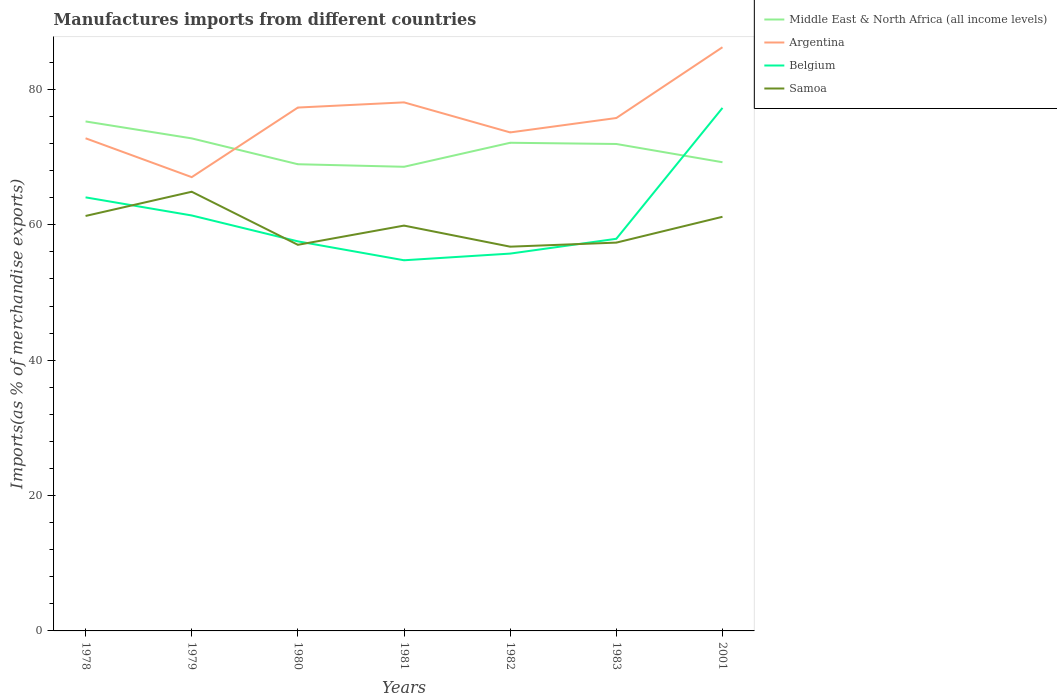Does the line corresponding to Belgium intersect with the line corresponding to Argentina?
Provide a succinct answer. No. Across all years, what is the maximum percentage of imports to different countries in Belgium?
Offer a terse response. 54.77. What is the total percentage of imports to different countries in Argentina in the graph?
Make the answer very short. -10.28. What is the difference between the highest and the second highest percentage of imports to different countries in Belgium?
Make the answer very short. 22.51. What is the difference between the highest and the lowest percentage of imports to different countries in Samoa?
Keep it short and to the point. 4. How many years are there in the graph?
Your answer should be compact. 7. Are the values on the major ticks of Y-axis written in scientific E-notation?
Keep it short and to the point. No. Does the graph contain grids?
Keep it short and to the point. No. What is the title of the graph?
Make the answer very short. Manufactures imports from different countries. Does "St. Vincent and the Grenadines" appear as one of the legend labels in the graph?
Ensure brevity in your answer.  No. What is the label or title of the Y-axis?
Your response must be concise. Imports(as % of merchandise exports). What is the Imports(as % of merchandise exports) of Middle East & North Africa (all income levels) in 1978?
Provide a short and direct response. 75.28. What is the Imports(as % of merchandise exports) of Argentina in 1978?
Provide a succinct answer. 72.79. What is the Imports(as % of merchandise exports) in Belgium in 1978?
Provide a short and direct response. 64.06. What is the Imports(as % of merchandise exports) in Samoa in 1978?
Ensure brevity in your answer.  61.31. What is the Imports(as % of merchandise exports) of Middle East & North Africa (all income levels) in 1979?
Make the answer very short. 72.78. What is the Imports(as % of merchandise exports) in Argentina in 1979?
Ensure brevity in your answer.  67.05. What is the Imports(as % of merchandise exports) in Belgium in 1979?
Provide a succinct answer. 61.39. What is the Imports(as % of merchandise exports) of Samoa in 1979?
Your answer should be very brief. 64.89. What is the Imports(as % of merchandise exports) of Middle East & North Africa (all income levels) in 1980?
Provide a succinct answer. 68.96. What is the Imports(as % of merchandise exports) in Argentina in 1980?
Make the answer very short. 77.33. What is the Imports(as % of merchandise exports) of Belgium in 1980?
Offer a very short reply. 57.56. What is the Imports(as % of merchandise exports) of Samoa in 1980?
Your answer should be very brief. 57.05. What is the Imports(as % of merchandise exports) in Middle East & North Africa (all income levels) in 1981?
Provide a short and direct response. 68.58. What is the Imports(as % of merchandise exports) in Argentina in 1981?
Ensure brevity in your answer.  78.1. What is the Imports(as % of merchandise exports) in Belgium in 1981?
Give a very brief answer. 54.77. What is the Imports(as % of merchandise exports) in Samoa in 1981?
Give a very brief answer. 59.89. What is the Imports(as % of merchandise exports) of Middle East & North Africa (all income levels) in 1982?
Offer a terse response. 72.13. What is the Imports(as % of merchandise exports) in Argentina in 1982?
Keep it short and to the point. 73.66. What is the Imports(as % of merchandise exports) in Belgium in 1982?
Your answer should be very brief. 55.75. What is the Imports(as % of merchandise exports) of Samoa in 1982?
Your answer should be compact. 56.78. What is the Imports(as % of merchandise exports) of Middle East & North Africa (all income levels) in 1983?
Give a very brief answer. 71.95. What is the Imports(as % of merchandise exports) of Argentina in 1983?
Offer a terse response. 75.79. What is the Imports(as % of merchandise exports) of Belgium in 1983?
Offer a terse response. 57.94. What is the Imports(as % of merchandise exports) in Samoa in 1983?
Provide a succinct answer. 57.38. What is the Imports(as % of merchandise exports) of Middle East & North Africa (all income levels) in 2001?
Keep it short and to the point. 69.25. What is the Imports(as % of merchandise exports) in Argentina in 2001?
Offer a very short reply. 86.25. What is the Imports(as % of merchandise exports) of Belgium in 2001?
Keep it short and to the point. 77.28. What is the Imports(as % of merchandise exports) in Samoa in 2001?
Keep it short and to the point. 61.19. Across all years, what is the maximum Imports(as % of merchandise exports) of Middle East & North Africa (all income levels)?
Make the answer very short. 75.28. Across all years, what is the maximum Imports(as % of merchandise exports) in Argentina?
Offer a very short reply. 86.25. Across all years, what is the maximum Imports(as % of merchandise exports) in Belgium?
Provide a short and direct response. 77.28. Across all years, what is the maximum Imports(as % of merchandise exports) of Samoa?
Give a very brief answer. 64.89. Across all years, what is the minimum Imports(as % of merchandise exports) in Middle East & North Africa (all income levels)?
Ensure brevity in your answer.  68.58. Across all years, what is the minimum Imports(as % of merchandise exports) of Argentina?
Your answer should be very brief. 67.05. Across all years, what is the minimum Imports(as % of merchandise exports) of Belgium?
Your answer should be compact. 54.77. Across all years, what is the minimum Imports(as % of merchandise exports) of Samoa?
Offer a very short reply. 56.78. What is the total Imports(as % of merchandise exports) of Middle East & North Africa (all income levels) in the graph?
Your answer should be compact. 498.92. What is the total Imports(as % of merchandise exports) of Argentina in the graph?
Offer a terse response. 530.96. What is the total Imports(as % of merchandise exports) of Belgium in the graph?
Make the answer very short. 428.75. What is the total Imports(as % of merchandise exports) in Samoa in the graph?
Keep it short and to the point. 418.49. What is the difference between the Imports(as % of merchandise exports) in Middle East & North Africa (all income levels) in 1978 and that in 1979?
Ensure brevity in your answer.  2.5. What is the difference between the Imports(as % of merchandise exports) in Argentina in 1978 and that in 1979?
Offer a very short reply. 5.74. What is the difference between the Imports(as % of merchandise exports) in Belgium in 1978 and that in 1979?
Offer a very short reply. 2.67. What is the difference between the Imports(as % of merchandise exports) in Samoa in 1978 and that in 1979?
Offer a very short reply. -3.58. What is the difference between the Imports(as % of merchandise exports) in Middle East & North Africa (all income levels) in 1978 and that in 1980?
Ensure brevity in your answer.  6.32. What is the difference between the Imports(as % of merchandise exports) of Argentina in 1978 and that in 1980?
Your answer should be compact. -4.54. What is the difference between the Imports(as % of merchandise exports) of Belgium in 1978 and that in 1980?
Provide a short and direct response. 6.5. What is the difference between the Imports(as % of merchandise exports) of Samoa in 1978 and that in 1980?
Offer a very short reply. 4.26. What is the difference between the Imports(as % of merchandise exports) of Middle East & North Africa (all income levels) in 1978 and that in 1981?
Your answer should be compact. 6.7. What is the difference between the Imports(as % of merchandise exports) in Argentina in 1978 and that in 1981?
Offer a very short reply. -5.31. What is the difference between the Imports(as % of merchandise exports) in Belgium in 1978 and that in 1981?
Your response must be concise. 9.29. What is the difference between the Imports(as % of merchandise exports) in Samoa in 1978 and that in 1981?
Your answer should be very brief. 1.42. What is the difference between the Imports(as % of merchandise exports) in Middle East & North Africa (all income levels) in 1978 and that in 1982?
Give a very brief answer. 3.15. What is the difference between the Imports(as % of merchandise exports) of Argentina in 1978 and that in 1982?
Ensure brevity in your answer.  -0.87. What is the difference between the Imports(as % of merchandise exports) in Belgium in 1978 and that in 1982?
Offer a terse response. 8.31. What is the difference between the Imports(as % of merchandise exports) in Samoa in 1978 and that in 1982?
Make the answer very short. 4.54. What is the difference between the Imports(as % of merchandise exports) of Middle East & North Africa (all income levels) in 1978 and that in 1983?
Offer a terse response. 3.33. What is the difference between the Imports(as % of merchandise exports) in Argentina in 1978 and that in 1983?
Keep it short and to the point. -2.99. What is the difference between the Imports(as % of merchandise exports) of Belgium in 1978 and that in 1983?
Keep it short and to the point. 6.12. What is the difference between the Imports(as % of merchandise exports) of Samoa in 1978 and that in 1983?
Provide a short and direct response. 3.94. What is the difference between the Imports(as % of merchandise exports) in Middle East & North Africa (all income levels) in 1978 and that in 2001?
Your answer should be compact. 6.03. What is the difference between the Imports(as % of merchandise exports) of Argentina in 1978 and that in 2001?
Offer a very short reply. -13.45. What is the difference between the Imports(as % of merchandise exports) of Belgium in 1978 and that in 2001?
Make the answer very short. -13.22. What is the difference between the Imports(as % of merchandise exports) in Samoa in 1978 and that in 2001?
Your answer should be compact. 0.12. What is the difference between the Imports(as % of merchandise exports) in Middle East & North Africa (all income levels) in 1979 and that in 1980?
Ensure brevity in your answer.  3.82. What is the difference between the Imports(as % of merchandise exports) of Argentina in 1979 and that in 1980?
Offer a terse response. -10.28. What is the difference between the Imports(as % of merchandise exports) of Belgium in 1979 and that in 1980?
Provide a short and direct response. 3.83. What is the difference between the Imports(as % of merchandise exports) of Samoa in 1979 and that in 1980?
Ensure brevity in your answer.  7.84. What is the difference between the Imports(as % of merchandise exports) of Middle East & North Africa (all income levels) in 1979 and that in 1981?
Provide a short and direct response. 4.2. What is the difference between the Imports(as % of merchandise exports) in Argentina in 1979 and that in 1981?
Offer a very short reply. -11.05. What is the difference between the Imports(as % of merchandise exports) of Belgium in 1979 and that in 1981?
Offer a very short reply. 6.62. What is the difference between the Imports(as % of merchandise exports) of Samoa in 1979 and that in 1981?
Your answer should be compact. 5. What is the difference between the Imports(as % of merchandise exports) of Middle East & North Africa (all income levels) in 1979 and that in 1982?
Make the answer very short. 0.65. What is the difference between the Imports(as % of merchandise exports) in Argentina in 1979 and that in 1982?
Your answer should be very brief. -6.61. What is the difference between the Imports(as % of merchandise exports) of Belgium in 1979 and that in 1982?
Your answer should be very brief. 5.63. What is the difference between the Imports(as % of merchandise exports) in Samoa in 1979 and that in 1982?
Keep it short and to the point. 8.12. What is the difference between the Imports(as % of merchandise exports) of Middle East & North Africa (all income levels) in 1979 and that in 1983?
Provide a short and direct response. 0.83. What is the difference between the Imports(as % of merchandise exports) in Argentina in 1979 and that in 1983?
Offer a terse response. -8.74. What is the difference between the Imports(as % of merchandise exports) in Belgium in 1979 and that in 1983?
Offer a terse response. 3.45. What is the difference between the Imports(as % of merchandise exports) of Samoa in 1979 and that in 1983?
Give a very brief answer. 7.52. What is the difference between the Imports(as % of merchandise exports) of Middle East & North Africa (all income levels) in 1979 and that in 2001?
Ensure brevity in your answer.  3.52. What is the difference between the Imports(as % of merchandise exports) of Argentina in 1979 and that in 2001?
Provide a succinct answer. -19.2. What is the difference between the Imports(as % of merchandise exports) of Belgium in 1979 and that in 2001?
Offer a terse response. -15.89. What is the difference between the Imports(as % of merchandise exports) in Samoa in 1979 and that in 2001?
Your response must be concise. 3.7. What is the difference between the Imports(as % of merchandise exports) in Middle East & North Africa (all income levels) in 1980 and that in 1981?
Keep it short and to the point. 0.38. What is the difference between the Imports(as % of merchandise exports) of Argentina in 1980 and that in 1981?
Keep it short and to the point. -0.77. What is the difference between the Imports(as % of merchandise exports) in Belgium in 1980 and that in 1981?
Your answer should be very brief. 2.79. What is the difference between the Imports(as % of merchandise exports) of Samoa in 1980 and that in 1981?
Offer a terse response. -2.84. What is the difference between the Imports(as % of merchandise exports) of Middle East & North Africa (all income levels) in 1980 and that in 1982?
Ensure brevity in your answer.  -3.17. What is the difference between the Imports(as % of merchandise exports) of Argentina in 1980 and that in 1982?
Give a very brief answer. 3.67. What is the difference between the Imports(as % of merchandise exports) in Belgium in 1980 and that in 1982?
Offer a very short reply. 1.81. What is the difference between the Imports(as % of merchandise exports) in Samoa in 1980 and that in 1982?
Keep it short and to the point. 0.27. What is the difference between the Imports(as % of merchandise exports) in Middle East & North Africa (all income levels) in 1980 and that in 1983?
Provide a short and direct response. -2.99. What is the difference between the Imports(as % of merchandise exports) in Argentina in 1980 and that in 1983?
Offer a terse response. 1.55. What is the difference between the Imports(as % of merchandise exports) of Belgium in 1980 and that in 1983?
Your answer should be very brief. -0.38. What is the difference between the Imports(as % of merchandise exports) of Samoa in 1980 and that in 1983?
Make the answer very short. -0.33. What is the difference between the Imports(as % of merchandise exports) in Middle East & North Africa (all income levels) in 1980 and that in 2001?
Give a very brief answer. -0.3. What is the difference between the Imports(as % of merchandise exports) in Argentina in 1980 and that in 2001?
Your answer should be very brief. -8.91. What is the difference between the Imports(as % of merchandise exports) of Belgium in 1980 and that in 2001?
Give a very brief answer. -19.72. What is the difference between the Imports(as % of merchandise exports) of Samoa in 1980 and that in 2001?
Your response must be concise. -4.14. What is the difference between the Imports(as % of merchandise exports) of Middle East & North Africa (all income levels) in 1981 and that in 1982?
Give a very brief answer. -3.55. What is the difference between the Imports(as % of merchandise exports) of Argentina in 1981 and that in 1982?
Provide a short and direct response. 4.44. What is the difference between the Imports(as % of merchandise exports) of Belgium in 1981 and that in 1982?
Offer a very short reply. -0.98. What is the difference between the Imports(as % of merchandise exports) of Samoa in 1981 and that in 1982?
Offer a terse response. 3.11. What is the difference between the Imports(as % of merchandise exports) in Middle East & North Africa (all income levels) in 1981 and that in 1983?
Provide a short and direct response. -3.37. What is the difference between the Imports(as % of merchandise exports) in Argentina in 1981 and that in 1983?
Keep it short and to the point. 2.31. What is the difference between the Imports(as % of merchandise exports) in Belgium in 1981 and that in 1983?
Your answer should be very brief. -3.17. What is the difference between the Imports(as % of merchandise exports) in Samoa in 1981 and that in 1983?
Your response must be concise. 2.51. What is the difference between the Imports(as % of merchandise exports) in Middle East & North Africa (all income levels) in 1981 and that in 2001?
Your answer should be compact. -0.67. What is the difference between the Imports(as % of merchandise exports) in Argentina in 1981 and that in 2001?
Offer a terse response. -8.15. What is the difference between the Imports(as % of merchandise exports) of Belgium in 1981 and that in 2001?
Your answer should be compact. -22.51. What is the difference between the Imports(as % of merchandise exports) of Samoa in 1981 and that in 2001?
Offer a very short reply. -1.3. What is the difference between the Imports(as % of merchandise exports) in Middle East & North Africa (all income levels) in 1982 and that in 1983?
Keep it short and to the point. 0.18. What is the difference between the Imports(as % of merchandise exports) in Argentina in 1982 and that in 1983?
Give a very brief answer. -2.13. What is the difference between the Imports(as % of merchandise exports) of Belgium in 1982 and that in 1983?
Your answer should be very brief. -2.19. What is the difference between the Imports(as % of merchandise exports) of Samoa in 1982 and that in 1983?
Your answer should be very brief. -0.6. What is the difference between the Imports(as % of merchandise exports) of Middle East & North Africa (all income levels) in 1982 and that in 2001?
Give a very brief answer. 2.88. What is the difference between the Imports(as % of merchandise exports) of Argentina in 1982 and that in 2001?
Provide a succinct answer. -12.59. What is the difference between the Imports(as % of merchandise exports) in Belgium in 1982 and that in 2001?
Provide a succinct answer. -21.53. What is the difference between the Imports(as % of merchandise exports) of Samoa in 1982 and that in 2001?
Your answer should be compact. -4.42. What is the difference between the Imports(as % of merchandise exports) in Middle East & North Africa (all income levels) in 1983 and that in 2001?
Provide a short and direct response. 2.7. What is the difference between the Imports(as % of merchandise exports) of Argentina in 1983 and that in 2001?
Make the answer very short. -10.46. What is the difference between the Imports(as % of merchandise exports) in Belgium in 1983 and that in 2001?
Offer a terse response. -19.34. What is the difference between the Imports(as % of merchandise exports) in Samoa in 1983 and that in 2001?
Offer a very short reply. -3.82. What is the difference between the Imports(as % of merchandise exports) in Middle East & North Africa (all income levels) in 1978 and the Imports(as % of merchandise exports) in Argentina in 1979?
Your answer should be very brief. 8.23. What is the difference between the Imports(as % of merchandise exports) of Middle East & North Africa (all income levels) in 1978 and the Imports(as % of merchandise exports) of Belgium in 1979?
Make the answer very short. 13.89. What is the difference between the Imports(as % of merchandise exports) of Middle East & North Africa (all income levels) in 1978 and the Imports(as % of merchandise exports) of Samoa in 1979?
Your response must be concise. 10.39. What is the difference between the Imports(as % of merchandise exports) of Argentina in 1978 and the Imports(as % of merchandise exports) of Belgium in 1979?
Provide a short and direct response. 11.4. What is the difference between the Imports(as % of merchandise exports) in Argentina in 1978 and the Imports(as % of merchandise exports) in Samoa in 1979?
Give a very brief answer. 7.9. What is the difference between the Imports(as % of merchandise exports) of Belgium in 1978 and the Imports(as % of merchandise exports) of Samoa in 1979?
Keep it short and to the point. -0.83. What is the difference between the Imports(as % of merchandise exports) of Middle East & North Africa (all income levels) in 1978 and the Imports(as % of merchandise exports) of Argentina in 1980?
Keep it short and to the point. -2.05. What is the difference between the Imports(as % of merchandise exports) in Middle East & North Africa (all income levels) in 1978 and the Imports(as % of merchandise exports) in Belgium in 1980?
Your answer should be compact. 17.72. What is the difference between the Imports(as % of merchandise exports) in Middle East & North Africa (all income levels) in 1978 and the Imports(as % of merchandise exports) in Samoa in 1980?
Your answer should be very brief. 18.23. What is the difference between the Imports(as % of merchandise exports) of Argentina in 1978 and the Imports(as % of merchandise exports) of Belgium in 1980?
Provide a succinct answer. 15.23. What is the difference between the Imports(as % of merchandise exports) of Argentina in 1978 and the Imports(as % of merchandise exports) of Samoa in 1980?
Your answer should be very brief. 15.74. What is the difference between the Imports(as % of merchandise exports) of Belgium in 1978 and the Imports(as % of merchandise exports) of Samoa in 1980?
Your response must be concise. 7.01. What is the difference between the Imports(as % of merchandise exports) of Middle East & North Africa (all income levels) in 1978 and the Imports(as % of merchandise exports) of Argentina in 1981?
Give a very brief answer. -2.82. What is the difference between the Imports(as % of merchandise exports) in Middle East & North Africa (all income levels) in 1978 and the Imports(as % of merchandise exports) in Belgium in 1981?
Your answer should be compact. 20.51. What is the difference between the Imports(as % of merchandise exports) of Middle East & North Africa (all income levels) in 1978 and the Imports(as % of merchandise exports) of Samoa in 1981?
Offer a very short reply. 15.39. What is the difference between the Imports(as % of merchandise exports) in Argentina in 1978 and the Imports(as % of merchandise exports) in Belgium in 1981?
Provide a short and direct response. 18.02. What is the difference between the Imports(as % of merchandise exports) of Argentina in 1978 and the Imports(as % of merchandise exports) of Samoa in 1981?
Your answer should be compact. 12.9. What is the difference between the Imports(as % of merchandise exports) in Belgium in 1978 and the Imports(as % of merchandise exports) in Samoa in 1981?
Your response must be concise. 4.17. What is the difference between the Imports(as % of merchandise exports) in Middle East & North Africa (all income levels) in 1978 and the Imports(as % of merchandise exports) in Argentina in 1982?
Your response must be concise. 1.62. What is the difference between the Imports(as % of merchandise exports) in Middle East & North Africa (all income levels) in 1978 and the Imports(as % of merchandise exports) in Belgium in 1982?
Your answer should be very brief. 19.53. What is the difference between the Imports(as % of merchandise exports) in Middle East & North Africa (all income levels) in 1978 and the Imports(as % of merchandise exports) in Samoa in 1982?
Provide a succinct answer. 18.5. What is the difference between the Imports(as % of merchandise exports) of Argentina in 1978 and the Imports(as % of merchandise exports) of Belgium in 1982?
Your response must be concise. 17.04. What is the difference between the Imports(as % of merchandise exports) in Argentina in 1978 and the Imports(as % of merchandise exports) in Samoa in 1982?
Your response must be concise. 16.02. What is the difference between the Imports(as % of merchandise exports) of Belgium in 1978 and the Imports(as % of merchandise exports) of Samoa in 1982?
Provide a succinct answer. 7.29. What is the difference between the Imports(as % of merchandise exports) in Middle East & North Africa (all income levels) in 1978 and the Imports(as % of merchandise exports) in Argentina in 1983?
Your response must be concise. -0.51. What is the difference between the Imports(as % of merchandise exports) of Middle East & North Africa (all income levels) in 1978 and the Imports(as % of merchandise exports) of Belgium in 1983?
Your answer should be very brief. 17.34. What is the difference between the Imports(as % of merchandise exports) in Middle East & North Africa (all income levels) in 1978 and the Imports(as % of merchandise exports) in Samoa in 1983?
Offer a very short reply. 17.9. What is the difference between the Imports(as % of merchandise exports) in Argentina in 1978 and the Imports(as % of merchandise exports) in Belgium in 1983?
Keep it short and to the point. 14.85. What is the difference between the Imports(as % of merchandise exports) of Argentina in 1978 and the Imports(as % of merchandise exports) of Samoa in 1983?
Your answer should be very brief. 15.42. What is the difference between the Imports(as % of merchandise exports) in Belgium in 1978 and the Imports(as % of merchandise exports) in Samoa in 1983?
Your response must be concise. 6.69. What is the difference between the Imports(as % of merchandise exports) in Middle East & North Africa (all income levels) in 1978 and the Imports(as % of merchandise exports) in Argentina in 2001?
Keep it short and to the point. -10.97. What is the difference between the Imports(as % of merchandise exports) in Middle East & North Africa (all income levels) in 1978 and the Imports(as % of merchandise exports) in Belgium in 2001?
Make the answer very short. -2. What is the difference between the Imports(as % of merchandise exports) of Middle East & North Africa (all income levels) in 1978 and the Imports(as % of merchandise exports) of Samoa in 2001?
Your answer should be very brief. 14.09. What is the difference between the Imports(as % of merchandise exports) in Argentina in 1978 and the Imports(as % of merchandise exports) in Belgium in 2001?
Make the answer very short. -4.49. What is the difference between the Imports(as % of merchandise exports) of Argentina in 1978 and the Imports(as % of merchandise exports) of Samoa in 2001?
Offer a very short reply. 11.6. What is the difference between the Imports(as % of merchandise exports) in Belgium in 1978 and the Imports(as % of merchandise exports) in Samoa in 2001?
Ensure brevity in your answer.  2.87. What is the difference between the Imports(as % of merchandise exports) of Middle East & North Africa (all income levels) in 1979 and the Imports(as % of merchandise exports) of Argentina in 1980?
Ensure brevity in your answer.  -4.56. What is the difference between the Imports(as % of merchandise exports) of Middle East & North Africa (all income levels) in 1979 and the Imports(as % of merchandise exports) of Belgium in 1980?
Your response must be concise. 15.21. What is the difference between the Imports(as % of merchandise exports) in Middle East & North Africa (all income levels) in 1979 and the Imports(as % of merchandise exports) in Samoa in 1980?
Keep it short and to the point. 15.73. What is the difference between the Imports(as % of merchandise exports) in Argentina in 1979 and the Imports(as % of merchandise exports) in Belgium in 1980?
Offer a terse response. 9.49. What is the difference between the Imports(as % of merchandise exports) in Argentina in 1979 and the Imports(as % of merchandise exports) in Samoa in 1980?
Provide a succinct answer. 10. What is the difference between the Imports(as % of merchandise exports) of Belgium in 1979 and the Imports(as % of merchandise exports) of Samoa in 1980?
Keep it short and to the point. 4.34. What is the difference between the Imports(as % of merchandise exports) in Middle East & North Africa (all income levels) in 1979 and the Imports(as % of merchandise exports) in Argentina in 1981?
Keep it short and to the point. -5.32. What is the difference between the Imports(as % of merchandise exports) of Middle East & North Africa (all income levels) in 1979 and the Imports(as % of merchandise exports) of Belgium in 1981?
Your response must be concise. 18.01. What is the difference between the Imports(as % of merchandise exports) of Middle East & North Africa (all income levels) in 1979 and the Imports(as % of merchandise exports) of Samoa in 1981?
Provide a succinct answer. 12.89. What is the difference between the Imports(as % of merchandise exports) of Argentina in 1979 and the Imports(as % of merchandise exports) of Belgium in 1981?
Offer a very short reply. 12.28. What is the difference between the Imports(as % of merchandise exports) of Argentina in 1979 and the Imports(as % of merchandise exports) of Samoa in 1981?
Offer a very short reply. 7.16. What is the difference between the Imports(as % of merchandise exports) in Belgium in 1979 and the Imports(as % of merchandise exports) in Samoa in 1981?
Provide a short and direct response. 1.5. What is the difference between the Imports(as % of merchandise exports) of Middle East & North Africa (all income levels) in 1979 and the Imports(as % of merchandise exports) of Argentina in 1982?
Make the answer very short. -0.88. What is the difference between the Imports(as % of merchandise exports) of Middle East & North Africa (all income levels) in 1979 and the Imports(as % of merchandise exports) of Belgium in 1982?
Ensure brevity in your answer.  17.02. What is the difference between the Imports(as % of merchandise exports) in Middle East & North Africa (all income levels) in 1979 and the Imports(as % of merchandise exports) in Samoa in 1982?
Your response must be concise. 16. What is the difference between the Imports(as % of merchandise exports) in Argentina in 1979 and the Imports(as % of merchandise exports) in Belgium in 1982?
Provide a short and direct response. 11.3. What is the difference between the Imports(as % of merchandise exports) of Argentina in 1979 and the Imports(as % of merchandise exports) of Samoa in 1982?
Ensure brevity in your answer.  10.27. What is the difference between the Imports(as % of merchandise exports) in Belgium in 1979 and the Imports(as % of merchandise exports) in Samoa in 1982?
Your answer should be compact. 4.61. What is the difference between the Imports(as % of merchandise exports) in Middle East & North Africa (all income levels) in 1979 and the Imports(as % of merchandise exports) in Argentina in 1983?
Offer a terse response. -3.01. What is the difference between the Imports(as % of merchandise exports) of Middle East & North Africa (all income levels) in 1979 and the Imports(as % of merchandise exports) of Belgium in 1983?
Offer a terse response. 14.84. What is the difference between the Imports(as % of merchandise exports) in Middle East & North Africa (all income levels) in 1979 and the Imports(as % of merchandise exports) in Samoa in 1983?
Provide a short and direct response. 15.4. What is the difference between the Imports(as % of merchandise exports) of Argentina in 1979 and the Imports(as % of merchandise exports) of Belgium in 1983?
Keep it short and to the point. 9.11. What is the difference between the Imports(as % of merchandise exports) of Argentina in 1979 and the Imports(as % of merchandise exports) of Samoa in 1983?
Offer a very short reply. 9.67. What is the difference between the Imports(as % of merchandise exports) in Belgium in 1979 and the Imports(as % of merchandise exports) in Samoa in 1983?
Your answer should be compact. 4.01. What is the difference between the Imports(as % of merchandise exports) in Middle East & North Africa (all income levels) in 1979 and the Imports(as % of merchandise exports) in Argentina in 2001?
Offer a terse response. -13.47. What is the difference between the Imports(as % of merchandise exports) of Middle East & North Africa (all income levels) in 1979 and the Imports(as % of merchandise exports) of Belgium in 2001?
Your answer should be compact. -4.5. What is the difference between the Imports(as % of merchandise exports) in Middle East & North Africa (all income levels) in 1979 and the Imports(as % of merchandise exports) in Samoa in 2001?
Ensure brevity in your answer.  11.58. What is the difference between the Imports(as % of merchandise exports) in Argentina in 1979 and the Imports(as % of merchandise exports) in Belgium in 2001?
Your answer should be very brief. -10.23. What is the difference between the Imports(as % of merchandise exports) of Argentina in 1979 and the Imports(as % of merchandise exports) of Samoa in 2001?
Ensure brevity in your answer.  5.86. What is the difference between the Imports(as % of merchandise exports) in Belgium in 1979 and the Imports(as % of merchandise exports) in Samoa in 2001?
Offer a terse response. 0.2. What is the difference between the Imports(as % of merchandise exports) in Middle East & North Africa (all income levels) in 1980 and the Imports(as % of merchandise exports) in Argentina in 1981?
Keep it short and to the point. -9.14. What is the difference between the Imports(as % of merchandise exports) of Middle East & North Africa (all income levels) in 1980 and the Imports(as % of merchandise exports) of Belgium in 1981?
Your response must be concise. 14.19. What is the difference between the Imports(as % of merchandise exports) of Middle East & North Africa (all income levels) in 1980 and the Imports(as % of merchandise exports) of Samoa in 1981?
Make the answer very short. 9.07. What is the difference between the Imports(as % of merchandise exports) of Argentina in 1980 and the Imports(as % of merchandise exports) of Belgium in 1981?
Your response must be concise. 22.56. What is the difference between the Imports(as % of merchandise exports) in Argentina in 1980 and the Imports(as % of merchandise exports) in Samoa in 1981?
Offer a very short reply. 17.44. What is the difference between the Imports(as % of merchandise exports) in Belgium in 1980 and the Imports(as % of merchandise exports) in Samoa in 1981?
Offer a very short reply. -2.33. What is the difference between the Imports(as % of merchandise exports) of Middle East & North Africa (all income levels) in 1980 and the Imports(as % of merchandise exports) of Argentina in 1982?
Your answer should be very brief. -4.7. What is the difference between the Imports(as % of merchandise exports) of Middle East & North Africa (all income levels) in 1980 and the Imports(as % of merchandise exports) of Belgium in 1982?
Offer a terse response. 13.2. What is the difference between the Imports(as % of merchandise exports) in Middle East & North Africa (all income levels) in 1980 and the Imports(as % of merchandise exports) in Samoa in 1982?
Provide a succinct answer. 12.18. What is the difference between the Imports(as % of merchandise exports) of Argentina in 1980 and the Imports(as % of merchandise exports) of Belgium in 1982?
Provide a short and direct response. 21.58. What is the difference between the Imports(as % of merchandise exports) in Argentina in 1980 and the Imports(as % of merchandise exports) in Samoa in 1982?
Provide a succinct answer. 20.56. What is the difference between the Imports(as % of merchandise exports) of Belgium in 1980 and the Imports(as % of merchandise exports) of Samoa in 1982?
Provide a succinct answer. 0.79. What is the difference between the Imports(as % of merchandise exports) of Middle East & North Africa (all income levels) in 1980 and the Imports(as % of merchandise exports) of Argentina in 1983?
Make the answer very short. -6.83. What is the difference between the Imports(as % of merchandise exports) in Middle East & North Africa (all income levels) in 1980 and the Imports(as % of merchandise exports) in Belgium in 1983?
Offer a very short reply. 11.02. What is the difference between the Imports(as % of merchandise exports) in Middle East & North Africa (all income levels) in 1980 and the Imports(as % of merchandise exports) in Samoa in 1983?
Provide a succinct answer. 11.58. What is the difference between the Imports(as % of merchandise exports) of Argentina in 1980 and the Imports(as % of merchandise exports) of Belgium in 1983?
Offer a terse response. 19.39. What is the difference between the Imports(as % of merchandise exports) of Argentina in 1980 and the Imports(as % of merchandise exports) of Samoa in 1983?
Offer a terse response. 19.96. What is the difference between the Imports(as % of merchandise exports) in Belgium in 1980 and the Imports(as % of merchandise exports) in Samoa in 1983?
Ensure brevity in your answer.  0.19. What is the difference between the Imports(as % of merchandise exports) of Middle East & North Africa (all income levels) in 1980 and the Imports(as % of merchandise exports) of Argentina in 2001?
Your response must be concise. -17.29. What is the difference between the Imports(as % of merchandise exports) in Middle East & North Africa (all income levels) in 1980 and the Imports(as % of merchandise exports) in Belgium in 2001?
Keep it short and to the point. -8.32. What is the difference between the Imports(as % of merchandise exports) of Middle East & North Africa (all income levels) in 1980 and the Imports(as % of merchandise exports) of Samoa in 2001?
Your answer should be compact. 7.76. What is the difference between the Imports(as % of merchandise exports) in Argentina in 1980 and the Imports(as % of merchandise exports) in Belgium in 2001?
Provide a succinct answer. 0.05. What is the difference between the Imports(as % of merchandise exports) in Argentina in 1980 and the Imports(as % of merchandise exports) in Samoa in 2001?
Keep it short and to the point. 16.14. What is the difference between the Imports(as % of merchandise exports) in Belgium in 1980 and the Imports(as % of merchandise exports) in Samoa in 2001?
Your response must be concise. -3.63. What is the difference between the Imports(as % of merchandise exports) in Middle East & North Africa (all income levels) in 1981 and the Imports(as % of merchandise exports) in Argentina in 1982?
Provide a succinct answer. -5.08. What is the difference between the Imports(as % of merchandise exports) of Middle East & North Africa (all income levels) in 1981 and the Imports(as % of merchandise exports) of Belgium in 1982?
Make the answer very short. 12.83. What is the difference between the Imports(as % of merchandise exports) in Middle East & North Africa (all income levels) in 1981 and the Imports(as % of merchandise exports) in Samoa in 1982?
Provide a short and direct response. 11.8. What is the difference between the Imports(as % of merchandise exports) of Argentina in 1981 and the Imports(as % of merchandise exports) of Belgium in 1982?
Your answer should be very brief. 22.34. What is the difference between the Imports(as % of merchandise exports) of Argentina in 1981 and the Imports(as % of merchandise exports) of Samoa in 1982?
Make the answer very short. 21.32. What is the difference between the Imports(as % of merchandise exports) in Belgium in 1981 and the Imports(as % of merchandise exports) in Samoa in 1982?
Keep it short and to the point. -2.01. What is the difference between the Imports(as % of merchandise exports) of Middle East & North Africa (all income levels) in 1981 and the Imports(as % of merchandise exports) of Argentina in 1983?
Give a very brief answer. -7.21. What is the difference between the Imports(as % of merchandise exports) in Middle East & North Africa (all income levels) in 1981 and the Imports(as % of merchandise exports) in Belgium in 1983?
Offer a terse response. 10.64. What is the difference between the Imports(as % of merchandise exports) of Middle East & North Africa (all income levels) in 1981 and the Imports(as % of merchandise exports) of Samoa in 1983?
Provide a short and direct response. 11.2. What is the difference between the Imports(as % of merchandise exports) in Argentina in 1981 and the Imports(as % of merchandise exports) in Belgium in 1983?
Provide a succinct answer. 20.16. What is the difference between the Imports(as % of merchandise exports) in Argentina in 1981 and the Imports(as % of merchandise exports) in Samoa in 1983?
Keep it short and to the point. 20.72. What is the difference between the Imports(as % of merchandise exports) of Belgium in 1981 and the Imports(as % of merchandise exports) of Samoa in 1983?
Ensure brevity in your answer.  -2.61. What is the difference between the Imports(as % of merchandise exports) in Middle East & North Africa (all income levels) in 1981 and the Imports(as % of merchandise exports) in Argentina in 2001?
Offer a very short reply. -17.67. What is the difference between the Imports(as % of merchandise exports) in Middle East & North Africa (all income levels) in 1981 and the Imports(as % of merchandise exports) in Belgium in 2001?
Offer a very short reply. -8.7. What is the difference between the Imports(as % of merchandise exports) in Middle East & North Africa (all income levels) in 1981 and the Imports(as % of merchandise exports) in Samoa in 2001?
Your answer should be compact. 7.39. What is the difference between the Imports(as % of merchandise exports) of Argentina in 1981 and the Imports(as % of merchandise exports) of Belgium in 2001?
Ensure brevity in your answer.  0.82. What is the difference between the Imports(as % of merchandise exports) in Argentina in 1981 and the Imports(as % of merchandise exports) in Samoa in 2001?
Your answer should be very brief. 16.91. What is the difference between the Imports(as % of merchandise exports) in Belgium in 1981 and the Imports(as % of merchandise exports) in Samoa in 2001?
Provide a short and direct response. -6.42. What is the difference between the Imports(as % of merchandise exports) of Middle East & North Africa (all income levels) in 1982 and the Imports(as % of merchandise exports) of Argentina in 1983?
Provide a succinct answer. -3.66. What is the difference between the Imports(as % of merchandise exports) in Middle East & North Africa (all income levels) in 1982 and the Imports(as % of merchandise exports) in Belgium in 1983?
Keep it short and to the point. 14.19. What is the difference between the Imports(as % of merchandise exports) in Middle East & North Africa (all income levels) in 1982 and the Imports(as % of merchandise exports) in Samoa in 1983?
Make the answer very short. 14.75. What is the difference between the Imports(as % of merchandise exports) of Argentina in 1982 and the Imports(as % of merchandise exports) of Belgium in 1983?
Offer a very short reply. 15.72. What is the difference between the Imports(as % of merchandise exports) of Argentina in 1982 and the Imports(as % of merchandise exports) of Samoa in 1983?
Your answer should be very brief. 16.28. What is the difference between the Imports(as % of merchandise exports) in Belgium in 1982 and the Imports(as % of merchandise exports) in Samoa in 1983?
Your response must be concise. -1.62. What is the difference between the Imports(as % of merchandise exports) in Middle East & North Africa (all income levels) in 1982 and the Imports(as % of merchandise exports) in Argentina in 2001?
Provide a succinct answer. -14.12. What is the difference between the Imports(as % of merchandise exports) in Middle East & North Africa (all income levels) in 1982 and the Imports(as % of merchandise exports) in Belgium in 2001?
Your answer should be very brief. -5.15. What is the difference between the Imports(as % of merchandise exports) of Middle East & North Africa (all income levels) in 1982 and the Imports(as % of merchandise exports) of Samoa in 2001?
Your answer should be very brief. 10.94. What is the difference between the Imports(as % of merchandise exports) in Argentina in 1982 and the Imports(as % of merchandise exports) in Belgium in 2001?
Your response must be concise. -3.62. What is the difference between the Imports(as % of merchandise exports) in Argentina in 1982 and the Imports(as % of merchandise exports) in Samoa in 2001?
Give a very brief answer. 12.47. What is the difference between the Imports(as % of merchandise exports) in Belgium in 1982 and the Imports(as % of merchandise exports) in Samoa in 2001?
Give a very brief answer. -5.44. What is the difference between the Imports(as % of merchandise exports) of Middle East & North Africa (all income levels) in 1983 and the Imports(as % of merchandise exports) of Argentina in 2001?
Your answer should be very brief. -14.3. What is the difference between the Imports(as % of merchandise exports) in Middle East & North Africa (all income levels) in 1983 and the Imports(as % of merchandise exports) in Belgium in 2001?
Provide a succinct answer. -5.33. What is the difference between the Imports(as % of merchandise exports) of Middle East & North Africa (all income levels) in 1983 and the Imports(as % of merchandise exports) of Samoa in 2001?
Provide a short and direct response. 10.76. What is the difference between the Imports(as % of merchandise exports) of Argentina in 1983 and the Imports(as % of merchandise exports) of Belgium in 2001?
Your answer should be very brief. -1.49. What is the difference between the Imports(as % of merchandise exports) of Argentina in 1983 and the Imports(as % of merchandise exports) of Samoa in 2001?
Provide a short and direct response. 14.59. What is the difference between the Imports(as % of merchandise exports) of Belgium in 1983 and the Imports(as % of merchandise exports) of Samoa in 2001?
Keep it short and to the point. -3.25. What is the average Imports(as % of merchandise exports) of Middle East & North Africa (all income levels) per year?
Offer a terse response. 71.27. What is the average Imports(as % of merchandise exports) in Argentina per year?
Keep it short and to the point. 75.85. What is the average Imports(as % of merchandise exports) of Belgium per year?
Ensure brevity in your answer.  61.25. What is the average Imports(as % of merchandise exports) in Samoa per year?
Ensure brevity in your answer.  59.78. In the year 1978, what is the difference between the Imports(as % of merchandise exports) of Middle East & North Africa (all income levels) and Imports(as % of merchandise exports) of Argentina?
Make the answer very short. 2.49. In the year 1978, what is the difference between the Imports(as % of merchandise exports) of Middle East & North Africa (all income levels) and Imports(as % of merchandise exports) of Belgium?
Provide a short and direct response. 11.22. In the year 1978, what is the difference between the Imports(as % of merchandise exports) in Middle East & North Africa (all income levels) and Imports(as % of merchandise exports) in Samoa?
Your answer should be very brief. 13.97. In the year 1978, what is the difference between the Imports(as % of merchandise exports) of Argentina and Imports(as % of merchandise exports) of Belgium?
Provide a short and direct response. 8.73. In the year 1978, what is the difference between the Imports(as % of merchandise exports) of Argentina and Imports(as % of merchandise exports) of Samoa?
Offer a terse response. 11.48. In the year 1978, what is the difference between the Imports(as % of merchandise exports) of Belgium and Imports(as % of merchandise exports) of Samoa?
Give a very brief answer. 2.75. In the year 1979, what is the difference between the Imports(as % of merchandise exports) in Middle East & North Africa (all income levels) and Imports(as % of merchandise exports) in Argentina?
Offer a terse response. 5.73. In the year 1979, what is the difference between the Imports(as % of merchandise exports) in Middle East & North Africa (all income levels) and Imports(as % of merchandise exports) in Belgium?
Ensure brevity in your answer.  11.39. In the year 1979, what is the difference between the Imports(as % of merchandise exports) of Middle East & North Africa (all income levels) and Imports(as % of merchandise exports) of Samoa?
Keep it short and to the point. 7.88. In the year 1979, what is the difference between the Imports(as % of merchandise exports) of Argentina and Imports(as % of merchandise exports) of Belgium?
Provide a short and direct response. 5.66. In the year 1979, what is the difference between the Imports(as % of merchandise exports) of Argentina and Imports(as % of merchandise exports) of Samoa?
Keep it short and to the point. 2.16. In the year 1979, what is the difference between the Imports(as % of merchandise exports) of Belgium and Imports(as % of merchandise exports) of Samoa?
Your answer should be compact. -3.51. In the year 1980, what is the difference between the Imports(as % of merchandise exports) of Middle East & North Africa (all income levels) and Imports(as % of merchandise exports) of Argentina?
Keep it short and to the point. -8.38. In the year 1980, what is the difference between the Imports(as % of merchandise exports) of Middle East & North Africa (all income levels) and Imports(as % of merchandise exports) of Belgium?
Keep it short and to the point. 11.39. In the year 1980, what is the difference between the Imports(as % of merchandise exports) in Middle East & North Africa (all income levels) and Imports(as % of merchandise exports) in Samoa?
Your answer should be compact. 11.91. In the year 1980, what is the difference between the Imports(as % of merchandise exports) in Argentina and Imports(as % of merchandise exports) in Belgium?
Make the answer very short. 19.77. In the year 1980, what is the difference between the Imports(as % of merchandise exports) in Argentina and Imports(as % of merchandise exports) in Samoa?
Your answer should be compact. 20.28. In the year 1980, what is the difference between the Imports(as % of merchandise exports) of Belgium and Imports(as % of merchandise exports) of Samoa?
Give a very brief answer. 0.51. In the year 1981, what is the difference between the Imports(as % of merchandise exports) of Middle East & North Africa (all income levels) and Imports(as % of merchandise exports) of Argentina?
Make the answer very short. -9.52. In the year 1981, what is the difference between the Imports(as % of merchandise exports) in Middle East & North Africa (all income levels) and Imports(as % of merchandise exports) in Belgium?
Your answer should be very brief. 13.81. In the year 1981, what is the difference between the Imports(as % of merchandise exports) in Middle East & North Africa (all income levels) and Imports(as % of merchandise exports) in Samoa?
Provide a succinct answer. 8.69. In the year 1981, what is the difference between the Imports(as % of merchandise exports) of Argentina and Imports(as % of merchandise exports) of Belgium?
Keep it short and to the point. 23.33. In the year 1981, what is the difference between the Imports(as % of merchandise exports) in Argentina and Imports(as % of merchandise exports) in Samoa?
Your answer should be very brief. 18.21. In the year 1981, what is the difference between the Imports(as % of merchandise exports) in Belgium and Imports(as % of merchandise exports) in Samoa?
Give a very brief answer. -5.12. In the year 1982, what is the difference between the Imports(as % of merchandise exports) in Middle East & North Africa (all income levels) and Imports(as % of merchandise exports) in Argentina?
Offer a very short reply. -1.53. In the year 1982, what is the difference between the Imports(as % of merchandise exports) in Middle East & North Africa (all income levels) and Imports(as % of merchandise exports) in Belgium?
Keep it short and to the point. 16.37. In the year 1982, what is the difference between the Imports(as % of merchandise exports) in Middle East & North Africa (all income levels) and Imports(as % of merchandise exports) in Samoa?
Your response must be concise. 15.35. In the year 1982, what is the difference between the Imports(as % of merchandise exports) of Argentina and Imports(as % of merchandise exports) of Belgium?
Ensure brevity in your answer.  17.91. In the year 1982, what is the difference between the Imports(as % of merchandise exports) of Argentina and Imports(as % of merchandise exports) of Samoa?
Your answer should be very brief. 16.88. In the year 1982, what is the difference between the Imports(as % of merchandise exports) in Belgium and Imports(as % of merchandise exports) in Samoa?
Offer a terse response. -1.02. In the year 1983, what is the difference between the Imports(as % of merchandise exports) of Middle East & North Africa (all income levels) and Imports(as % of merchandise exports) of Argentina?
Your answer should be very brief. -3.84. In the year 1983, what is the difference between the Imports(as % of merchandise exports) in Middle East & North Africa (all income levels) and Imports(as % of merchandise exports) in Belgium?
Make the answer very short. 14.01. In the year 1983, what is the difference between the Imports(as % of merchandise exports) of Middle East & North Africa (all income levels) and Imports(as % of merchandise exports) of Samoa?
Your answer should be very brief. 14.57. In the year 1983, what is the difference between the Imports(as % of merchandise exports) in Argentina and Imports(as % of merchandise exports) in Belgium?
Keep it short and to the point. 17.85. In the year 1983, what is the difference between the Imports(as % of merchandise exports) of Argentina and Imports(as % of merchandise exports) of Samoa?
Your answer should be compact. 18.41. In the year 1983, what is the difference between the Imports(as % of merchandise exports) in Belgium and Imports(as % of merchandise exports) in Samoa?
Keep it short and to the point. 0.56. In the year 2001, what is the difference between the Imports(as % of merchandise exports) in Middle East & North Africa (all income levels) and Imports(as % of merchandise exports) in Argentina?
Ensure brevity in your answer.  -16.99. In the year 2001, what is the difference between the Imports(as % of merchandise exports) of Middle East & North Africa (all income levels) and Imports(as % of merchandise exports) of Belgium?
Provide a short and direct response. -8.03. In the year 2001, what is the difference between the Imports(as % of merchandise exports) of Middle East & North Africa (all income levels) and Imports(as % of merchandise exports) of Samoa?
Make the answer very short. 8.06. In the year 2001, what is the difference between the Imports(as % of merchandise exports) in Argentina and Imports(as % of merchandise exports) in Belgium?
Your answer should be very brief. 8.97. In the year 2001, what is the difference between the Imports(as % of merchandise exports) in Argentina and Imports(as % of merchandise exports) in Samoa?
Provide a short and direct response. 25.05. In the year 2001, what is the difference between the Imports(as % of merchandise exports) in Belgium and Imports(as % of merchandise exports) in Samoa?
Make the answer very short. 16.09. What is the ratio of the Imports(as % of merchandise exports) of Middle East & North Africa (all income levels) in 1978 to that in 1979?
Provide a succinct answer. 1.03. What is the ratio of the Imports(as % of merchandise exports) of Argentina in 1978 to that in 1979?
Make the answer very short. 1.09. What is the ratio of the Imports(as % of merchandise exports) in Belgium in 1978 to that in 1979?
Provide a short and direct response. 1.04. What is the ratio of the Imports(as % of merchandise exports) of Samoa in 1978 to that in 1979?
Provide a short and direct response. 0.94. What is the ratio of the Imports(as % of merchandise exports) of Middle East & North Africa (all income levels) in 1978 to that in 1980?
Ensure brevity in your answer.  1.09. What is the ratio of the Imports(as % of merchandise exports) of Argentina in 1978 to that in 1980?
Make the answer very short. 0.94. What is the ratio of the Imports(as % of merchandise exports) in Belgium in 1978 to that in 1980?
Offer a very short reply. 1.11. What is the ratio of the Imports(as % of merchandise exports) of Samoa in 1978 to that in 1980?
Make the answer very short. 1.07. What is the ratio of the Imports(as % of merchandise exports) of Middle East & North Africa (all income levels) in 1978 to that in 1981?
Provide a succinct answer. 1.1. What is the ratio of the Imports(as % of merchandise exports) of Argentina in 1978 to that in 1981?
Your response must be concise. 0.93. What is the ratio of the Imports(as % of merchandise exports) in Belgium in 1978 to that in 1981?
Provide a succinct answer. 1.17. What is the ratio of the Imports(as % of merchandise exports) of Samoa in 1978 to that in 1981?
Your response must be concise. 1.02. What is the ratio of the Imports(as % of merchandise exports) of Middle East & North Africa (all income levels) in 1978 to that in 1982?
Give a very brief answer. 1.04. What is the ratio of the Imports(as % of merchandise exports) of Belgium in 1978 to that in 1982?
Offer a terse response. 1.15. What is the ratio of the Imports(as % of merchandise exports) of Samoa in 1978 to that in 1982?
Give a very brief answer. 1.08. What is the ratio of the Imports(as % of merchandise exports) of Middle East & North Africa (all income levels) in 1978 to that in 1983?
Your answer should be compact. 1.05. What is the ratio of the Imports(as % of merchandise exports) in Argentina in 1978 to that in 1983?
Offer a very short reply. 0.96. What is the ratio of the Imports(as % of merchandise exports) in Belgium in 1978 to that in 1983?
Keep it short and to the point. 1.11. What is the ratio of the Imports(as % of merchandise exports) in Samoa in 1978 to that in 1983?
Provide a succinct answer. 1.07. What is the ratio of the Imports(as % of merchandise exports) in Middle East & North Africa (all income levels) in 1978 to that in 2001?
Make the answer very short. 1.09. What is the ratio of the Imports(as % of merchandise exports) of Argentina in 1978 to that in 2001?
Offer a very short reply. 0.84. What is the ratio of the Imports(as % of merchandise exports) in Belgium in 1978 to that in 2001?
Your response must be concise. 0.83. What is the ratio of the Imports(as % of merchandise exports) of Middle East & North Africa (all income levels) in 1979 to that in 1980?
Provide a short and direct response. 1.06. What is the ratio of the Imports(as % of merchandise exports) of Argentina in 1979 to that in 1980?
Keep it short and to the point. 0.87. What is the ratio of the Imports(as % of merchandise exports) of Belgium in 1979 to that in 1980?
Your answer should be compact. 1.07. What is the ratio of the Imports(as % of merchandise exports) of Samoa in 1979 to that in 1980?
Your response must be concise. 1.14. What is the ratio of the Imports(as % of merchandise exports) of Middle East & North Africa (all income levels) in 1979 to that in 1981?
Make the answer very short. 1.06. What is the ratio of the Imports(as % of merchandise exports) in Argentina in 1979 to that in 1981?
Provide a succinct answer. 0.86. What is the ratio of the Imports(as % of merchandise exports) of Belgium in 1979 to that in 1981?
Your answer should be very brief. 1.12. What is the ratio of the Imports(as % of merchandise exports) in Samoa in 1979 to that in 1981?
Offer a very short reply. 1.08. What is the ratio of the Imports(as % of merchandise exports) in Argentina in 1979 to that in 1982?
Offer a very short reply. 0.91. What is the ratio of the Imports(as % of merchandise exports) of Belgium in 1979 to that in 1982?
Offer a very short reply. 1.1. What is the ratio of the Imports(as % of merchandise exports) in Samoa in 1979 to that in 1982?
Your response must be concise. 1.14. What is the ratio of the Imports(as % of merchandise exports) of Middle East & North Africa (all income levels) in 1979 to that in 1983?
Your answer should be compact. 1.01. What is the ratio of the Imports(as % of merchandise exports) in Argentina in 1979 to that in 1983?
Offer a terse response. 0.88. What is the ratio of the Imports(as % of merchandise exports) in Belgium in 1979 to that in 1983?
Ensure brevity in your answer.  1.06. What is the ratio of the Imports(as % of merchandise exports) in Samoa in 1979 to that in 1983?
Give a very brief answer. 1.13. What is the ratio of the Imports(as % of merchandise exports) in Middle East & North Africa (all income levels) in 1979 to that in 2001?
Your answer should be very brief. 1.05. What is the ratio of the Imports(as % of merchandise exports) in Argentina in 1979 to that in 2001?
Provide a short and direct response. 0.78. What is the ratio of the Imports(as % of merchandise exports) of Belgium in 1979 to that in 2001?
Make the answer very short. 0.79. What is the ratio of the Imports(as % of merchandise exports) in Samoa in 1979 to that in 2001?
Your answer should be very brief. 1.06. What is the ratio of the Imports(as % of merchandise exports) of Argentina in 1980 to that in 1981?
Keep it short and to the point. 0.99. What is the ratio of the Imports(as % of merchandise exports) in Belgium in 1980 to that in 1981?
Keep it short and to the point. 1.05. What is the ratio of the Imports(as % of merchandise exports) in Samoa in 1980 to that in 1981?
Provide a succinct answer. 0.95. What is the ratio of the Imports(as % of merchandise exports) in Middle East & North Africa (all income levels) in 1980 to that in 1982?
Give a very brief answer. 0.96. What is the ratio of the Imports(as % of merchandise exports) in Argentina in 1980 to that in 1982?
Provide a short and direct response. 1.05. What is the ratio of the Imports(as % of merchandise exports) of Belgium in 1980 to that in 1982?
Your response must be concise. 1.03. What is the ratio of the Imports(as % of merchandise exports) in Samoa in 1980 to that in 1982?
Offer a very short reply. 1. What is the ratio of the Imports(as % of merchandise exports) of Middle East & North Africa (all income levels) in 1980 to that in 1983?
Provide a succinct answer. 0.96. What is the ratio of the Imports(as % of merchandise exports) of Argentina in 1980 to that in 1983?
Ensure brevity in your answer.  1.02. What is the ratio of the Imports(as % of merchandise exports) of Belgium in 1980 to that in 1983?
Ensure brevity in your answer.  0.99. What is the ratio of the Imports(as % of merchandise exports) of Samoa in 1980 to that in 1983?
Offer a terse response. 0.99. What is the ratio of the Imports(as % of merchandise exports) of Argentina in 1980 to that in 2001?
Offer a terse response. 0.9. What is the ratio of the Imports(as % of merchandise exports) in Belgium in 1980 to that in 2001?
Offer a terse response. 0.74. What is the ratio of the Imports(as % of merchandise exports) of Samoa in 1980 to that in 2001?
Provide a succinct answer. 0.93. What is the ratio of the Imports(as % of merchandise exports) in Middle East & North Africa (all income levels) in 1981 to that in 1982?
Make the answer very short. 0.95. What is the ratio of the Imports(as % of merchandise exports) in Argentina in 1981 to that in 1982?
Provide a short and direct response. 1.06. What is the ratio of the Imports(as % of merchandise exports) of Belgium in 1981 to that in 1982?
Provide a succinct answer. 0.98. What is the ratio of the Imports(as % of merchandise exports) of Samoa in 1981 to that in 1982?
Ensure brevity in your answer.  1.05. What is the ratio of the Imports(as % of merchandise exports) of Middle East & North Africa (all income levels) in 1981 to that in 1983?
Your response must be concise. 0.95. What is the ratio of the Imports(as % of merchandise exports) in Argentina in 1981 to that in 1983?
Keep it short and to the point. 1.03. What is the ratio of the Imports(as % of merchandise exports) of Belgium in 1981 to that in 1983?
Offer a very short reply. 0.95. What is the ratio of the Imports(as % of merchandise exports) of Samoa in 1981 to that in 1983?
Your response must be concise. 1.04. What is the ratio of the Imports(as % of merchandise exports) in Middle East & North Africa (all income levels) in 1981 to that in 2001?
Provide a succinct answer. 0.99. What is the ratio of the Imports(as % of merchandise exports) in Argentina in 1981 to that in 2001?
Offer a very short reply. 0.91. What is the ratio of the Imports(as % of merchandise exports) of Belgium in 1981 to that in 2001?
Give a very brief answer. 0.71. What is the ratio of the Imports(as % of merchandise exports) of Samoa in 1981 to that in 2001?
Give a very brief answer. 0.98. What is the ratio of the Imports(as % of merchandise exports) of Middle East & North Africa (all income levels) in 1982 to that in 1983?
Offer a terse response. 1. What is the ratio of the Imports(as % of merchandise exports) in Argentina in 1982 to that in 1983?
Your answer should be compact. 0.97. What is the ratio of the Imports(as % of merchandise exports) of Belgium in 1982 to that in 1983?
Your response must be concise. 0.96. What is the ratio of the Imports(as % of merchandise exports) in Samoa in 1982 to that in 1983?
Make the answer very short. 0.99. What is the ratio of the Imports(as % of merchandise exports) of Middle East & North Africa (all income levels) in 1982 to that in 2001?
Keep it short and to the point. 1.04. What is the ratio of the Imports(as % of merchandise exports) of Argentina in 1982 to that in 2001?
Provide a succinct answer. 0.85. What is the ratio of the Imports(as % of merchandise exports) of Belgium in 1982 to that in 2001?
Your answer should be compact. 0.72. What is the ratio of the Imports(as % of merchandise exports) of Samoa in 1982 to that in 2001?
Give a very brief answer. 0.93. What is the ratio of the Imports(as % of merchandise exports) in Middle East & North Africa (all income levels) in 1983 to that in 2001?
Make the answer very short. 1.04. What is the ratio of the Imports(as % of merchandise exports) in Argentina in 1983 to that in 2001?
Make the answer very short. 0.88. What is the ratio of the Imports(as % of merchandise exports) in Belgium in 1983 to that in 2001?
Provide a short and direct response. 0.75. What is the ratio of the Imports(as % of merchandise exports) in Samoa in 1983 to that in 2001?
Your answer should be compact. 0.94. What is the difference between the highest and the second highest Imports(as % of merchandise exports) in Middle East & North Africa (all income levels)?
Give a very brief answer. 2.5. What is the difference between the highest and the second highest Imports(as % of merchandise exports) of Argentina?
Ensure brevity in your answer.  8.15. What is the difference between the highest and the second highest Imports(as % of merchandise exports) of Belgium?
Offer a very short reply. 13.22. What is the difference between the highest and the second highest Imports(as % of merchandise exports) in Samoa?
Provide a short and direct response. 3.58. What is the difference between the highest and the lowest Imports(as % of merchandise exports) in Middle East & North Africa (all income levels)?
Your answer should be very brief. 6.7. What is the difference between the highest and the lowest Imports(as % of merchandise exports) in Argentina?
Provide a succinct answer. 19.2. What is the difference between the highest and the lowest Imports(as % of merchandise exports) of Belgium?
Your response must be concise. 22.51. What is the difference between the highest and the lowest Imports(as % of merchandise exports) in Samoa?
Your answer should be very brief. 8.12. 